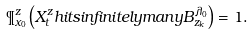<formula> <loc_0><loc_0><loc_500><loc_500>\P ^ { z } _ { x _ { 0 } } \left ( X ^ { z } _ { t } h i t s i n f i n i t e l y m a n y B ^ { \lambda _ { 0 } } _ { z _ { k } } \right ) = 1 .</formula> 